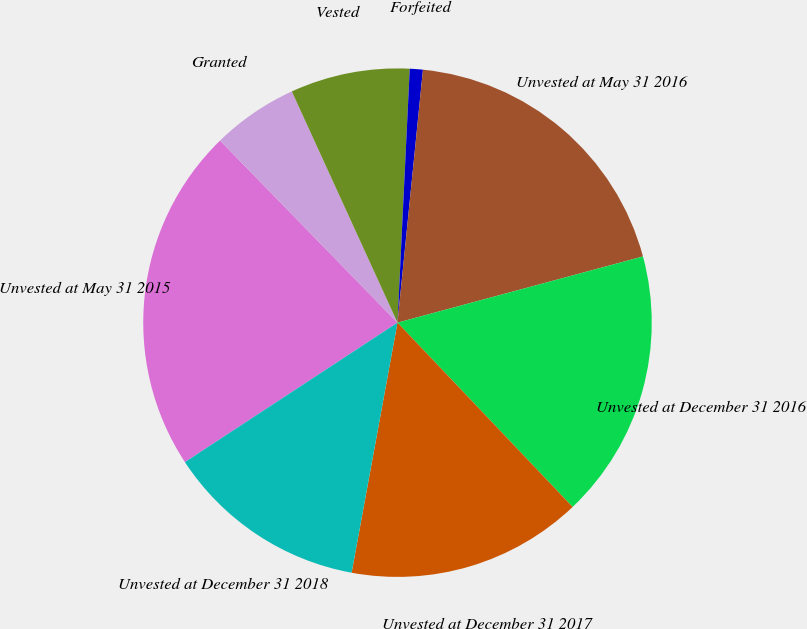Convert chart to OTSL. <chart><loc_0><loc_0><loc_500><loc_500><pie_chart><fcel>Unvested at May 31 2015<fcel>Granted<fcel>Vested<fcel>Forfeited<fcel>Unvested at May 31 2016<fcel>Unvested at December 31 2016<fcel>Unvested at December 31 2017<fcel>Unvested at December 31 2018<nl><fcel>21.95%<fcel>5.47%<fcel>7.59%<fcel>0.83%<fcel>19.21%<fcel>17.1%<fcel>14.98%<fcel>12.87%<nl></chart> 